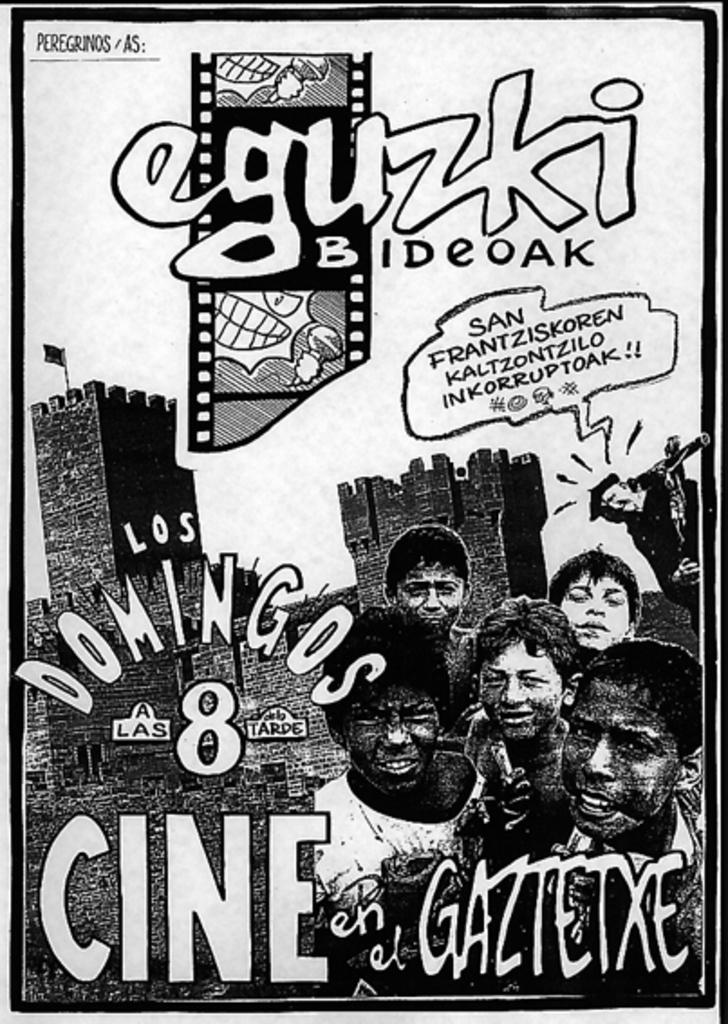What is present in the image? There is a poster in the image. What can be seen in the picture on the poster? The picture on the poster is a black and white image of people. What else is included on the poster besides the picture? The poster includes text. What type of muscle is being flexed by the person in the image? There is no person flexing a muscle in the image; it features a black and white picture of people. Can you tell me how many kettles are visible in the image? There are no kettles present in the image. 